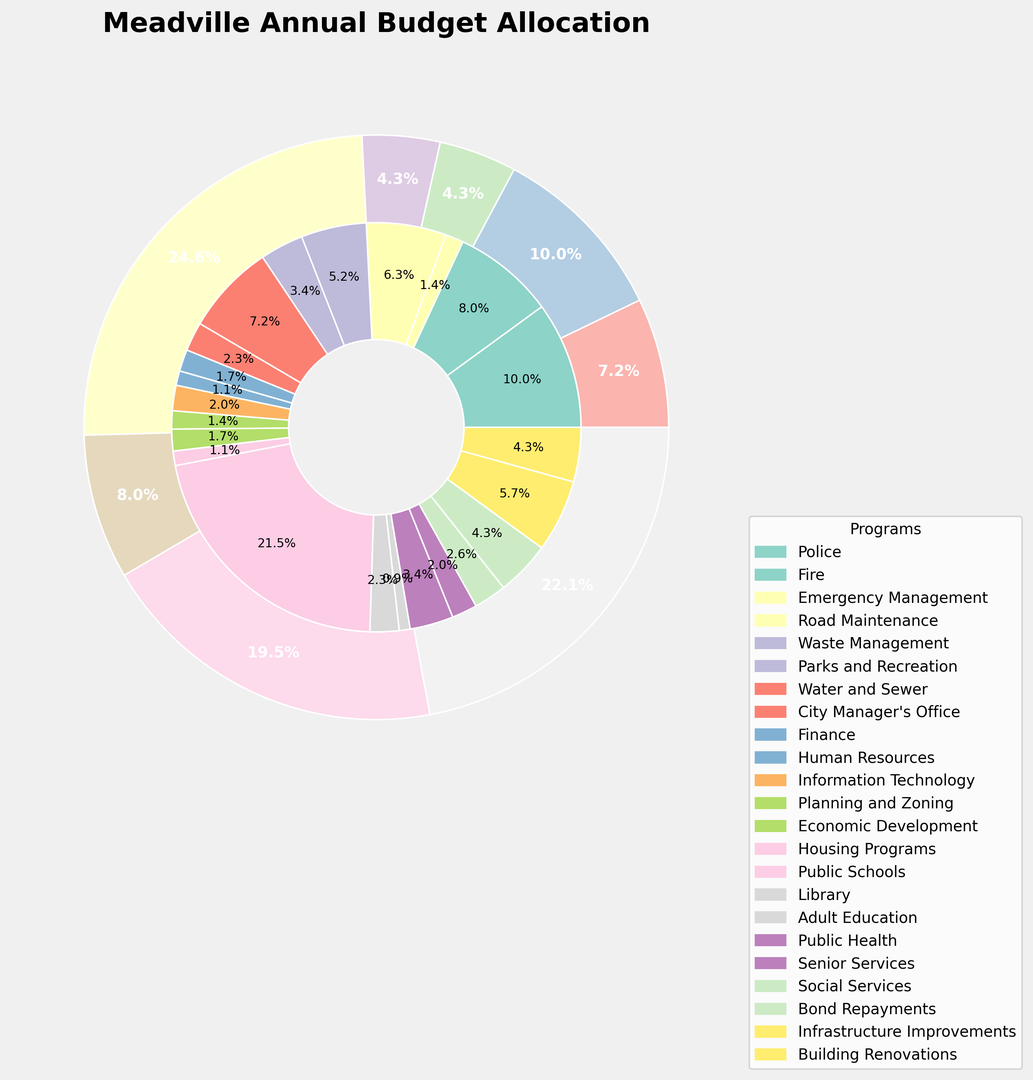Which department has the largest share of the annual budget? To determine which department has the largest share, we need to look at the outer pie chart sections, which represent departments. The largest wedge corresponds to Education.
Answer: Education What is the budget allocated to all Public Works programs combined? To find the total budget for Public Works programs, we sum the budgets for each program within this department: Road Maintenance ($2,200,000), Waste Management ($1,800,000), Parks and Recreation ($1,200,000), and Water and Sewer ($2,500,000). Thus, $2,200,000 + $1,800,000 + $1,200,000 + $2,500,000 = $7,700,000
Answer: $7,700,000 Which program has the smallest budget allocation? To find the program with the smallest budget, we look at the inner wedges of the pie chart. The smallest wedge corresponds to Adult Education.
Answer: Adult Education How does the budget for Health and Welfare compare to Debt Service? By comparing the wedges of these two departments in the outer pie chart, we see that Health and Welfare has a larger budget allocation than Debt Service.
Answer: Health and Welfare has a larger budget What proportion of the Public Safety budget is allocated to the Emergency Management program? First, determine the total budget for Public Safety: Police ($3,500,000), Fire ($2,800,000), and Emergency Management ($500,000), so $3,500,000 + $2,800,000 + $500,000 = $6,800,000. The proportion for Emergency Management is then $500,000 / $6,800,000 = 0.0735 or 7.35%
Answer: 7.35% What is the average budget allocation for programs under Administration? The programs under Administration are City Manager's Office ($800,000), Finance ($600,000), Human Resources ($400,000), and Information Technology ($700,000). Their total budget is $800,000 + $600,000 + $400,000 + $700,000 = $2,500,000. With 4 programs, the average is $2,500,000 / 4 = $625,000
Answer: $625,000 How does the budget for Education compare to the combined budget for Community Development and Capital Projects? Education's budget is $7,500,000 (Public Schools) + $800,000 (Library) + $300,000 (Adult Education) = $8,600,000. Community Development's budget is $500,000 (Planning and Zoning) + $600,000 (Economic Development) + $400,000 (Housing Programs) = $1,500,000. Capital Projects' budget is $2,000,000 (Infrastructure Improvements) + $1,500,000 (Building Renovations) = $3,500,000. Combined, Community Development and Capital Projects total $1,500,000 + $3,500,000 = $5,000,000. Comparing the two, Education is larger at $8,600,000 vs $5,000,000.
Answer: Education: $8,600,000, Combined: $5,000,000 